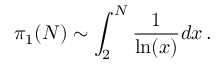Convert formula to latex. <formula><loc_0><loc_0><loc_500><loc_500>\pi _ { 1 } ( N ) \sim \int _ { 2 } ^ { N } \frac { 1 } { \ln ( x ) } d x \, .</formula> 